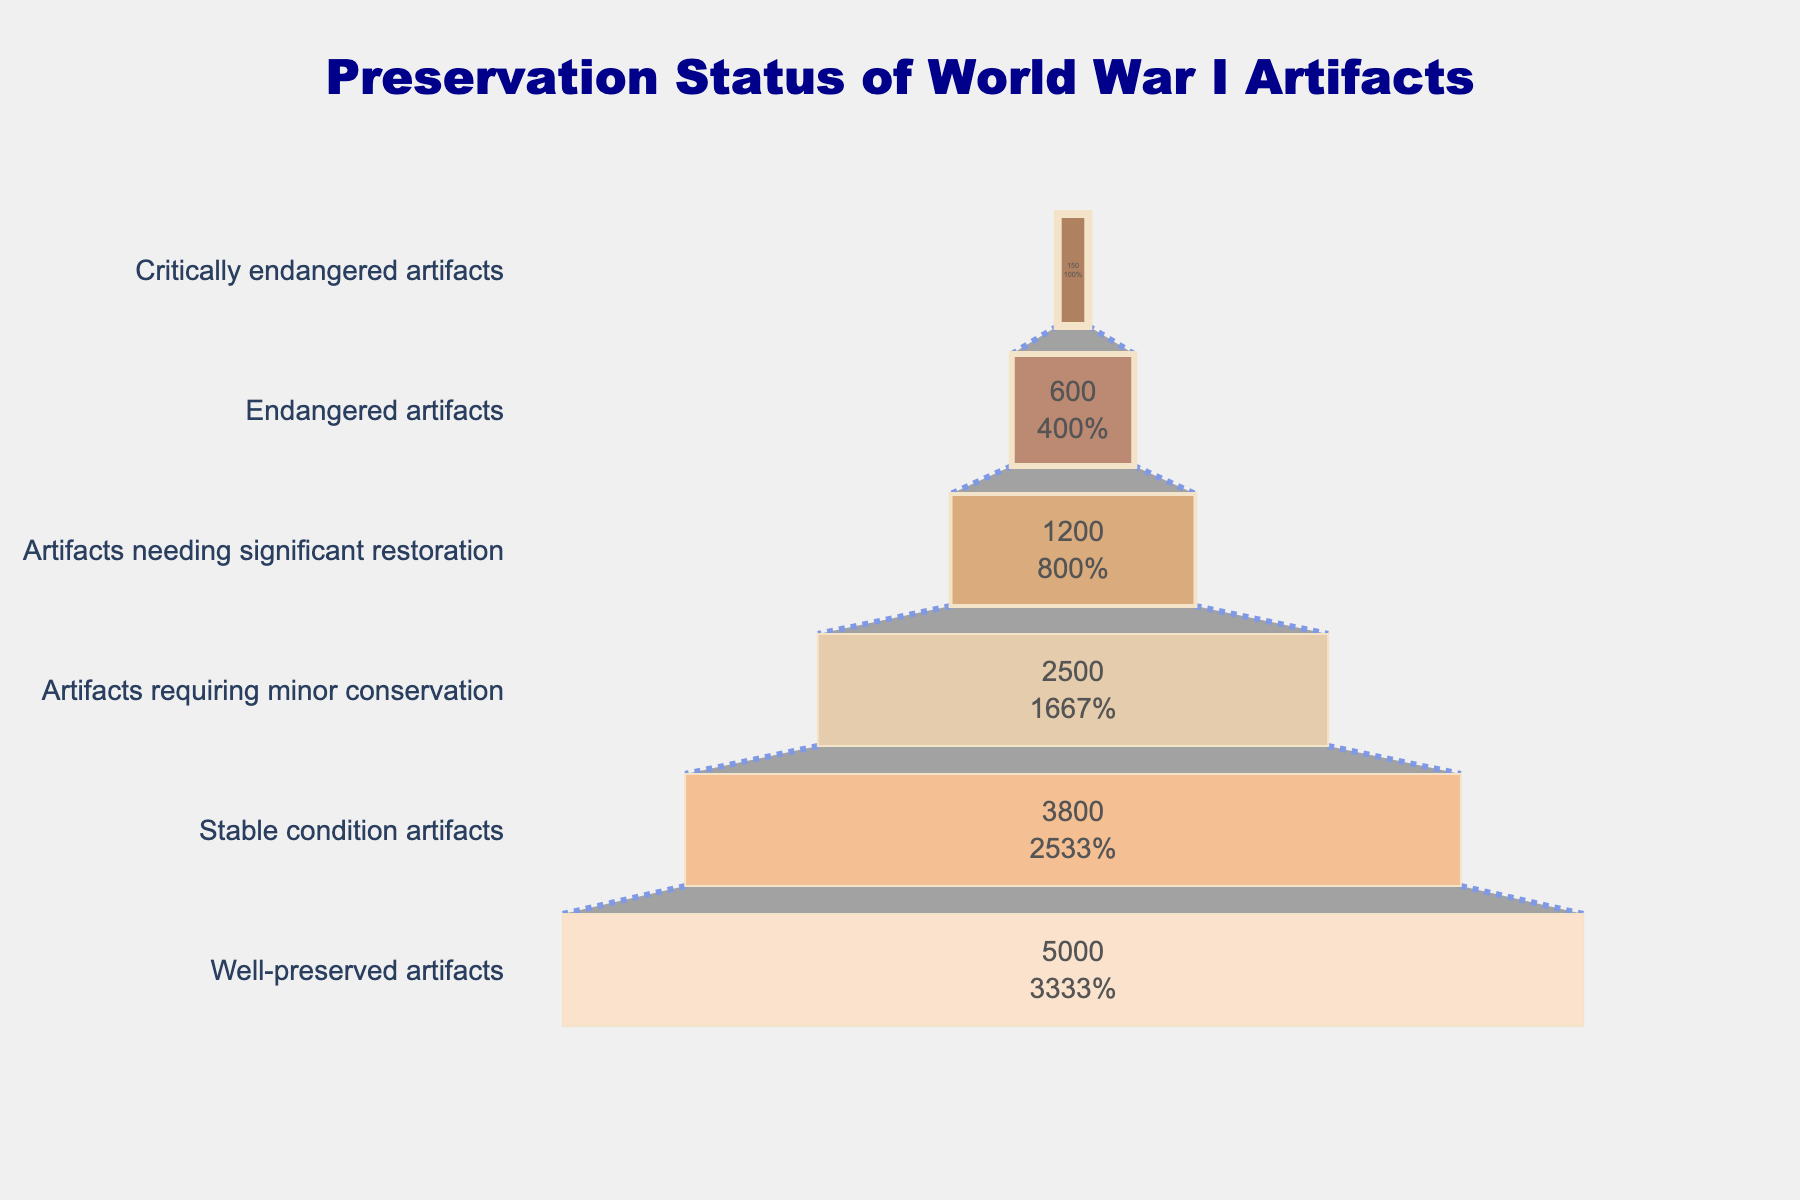What is the title of the chart? The title of the chart is located at the top center. It reads "Preservation Status of World War I Artifacts".
Answer: Preservation Status of World War I Artifacts How many categories are displayed in the funnel chart? To determine the number of categories, we count the distinct levels in the chart. There are six distinct categories from "Well-preserved artifacts" to "Critically endangered artifacts".
Answer: Six Which category has the largest count? The "Well-preserved artifacts" category is at the widest part of the funnel, indicating it has the largest count.
Answer: Well-preserved artifacts What percentage of the initial count does the "Artifacts needing significant restoration" category represent? To find the percentage, look at the value displayed inside the "Artifacts needing significant restoration" section. It shows the value and percentage relative to the initial count.
Answer: 12% How many artifacts are critically endangered? The funnel section for "Critically endangered artifacts" shows the count directly inside the section.
Answer: 150 What is the difference in count between "Well-preserved artifacts" and "Critically endangered artifacts"? Subtract the count of "Critically endangered artifacts" from "Well-preserved artifacts": 5000 - 150 = 4850.
Answer: 4850 What is the combined count of artifacts that are well-preserved or in stable condition? Add the counts of "Well-preserved artifacts" and "Stable condition artifacts": 5000 + 3800 = 8800.
Answer: 8800 Which category needs more restoration: "Artifacts requiring minor conservation" or "Artifacts needing significant restoration"? Compare the two categories. "Artifacts requiring minor conservation" has 2500 artifacts, while "Artifacts needing significant restoration" has 1200 artifacts.
Answer: Artifacts requiring minor conservation What is the median value of the counts among all categories? Arrange the counts in ascending order: 150, 600, 1200, 2500, 3800, 5000. The median is the average of the middle two values: (2500 + 1200) / 2 = 1850.
Answer: 1850 What percent of the initial artifacts are considered endangered or critically endangered? Add the counts for the "Endangered artifacts" and "Critically endangered artifacts": 600 + 150 = 750. Divide by the initial count (5000) and multiply by 100: (750 / 5000) * 100 = 15%.
Answer: 15% 